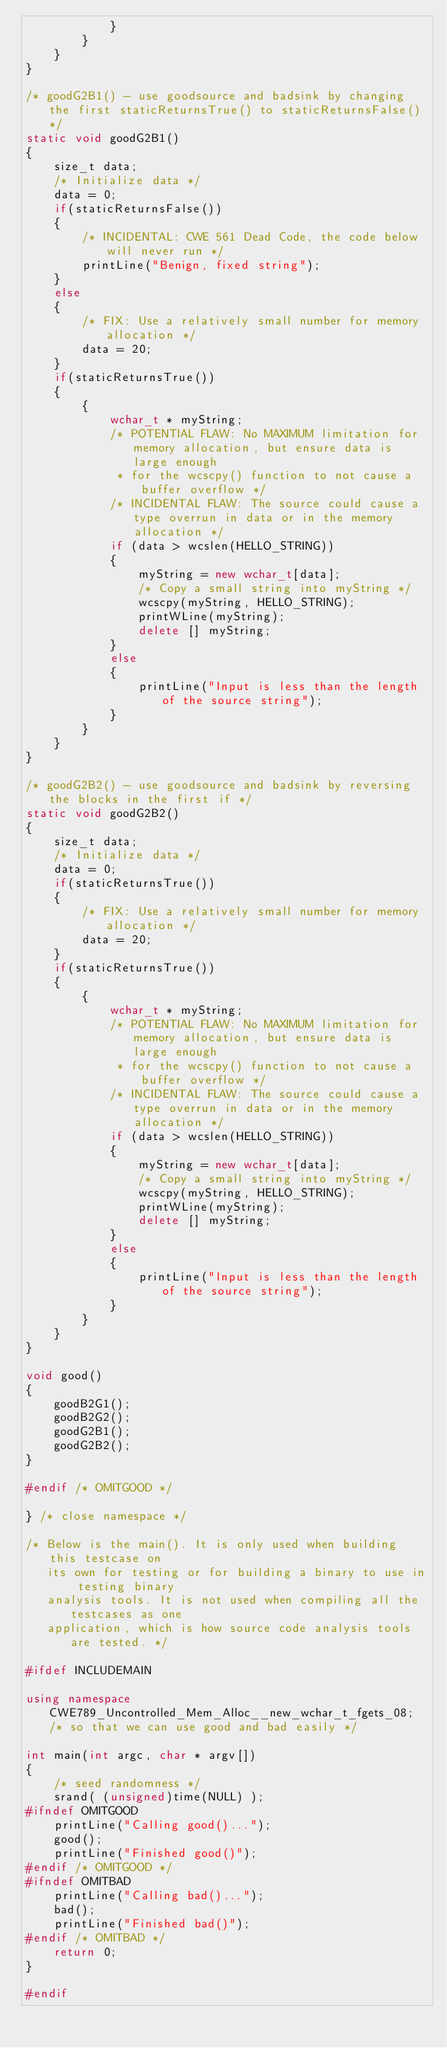<code> <loc_0><loc_0><loc_500><loc_500><_C++_>            }
        }
    }
}

/* goodG2B1() - use goodsource and badsink by changing the first staticReturnsTrue() to staticReturnsFalse() */
static void goodG2B1()
{
    size_t data;
    /* Initialize data */
    data = 0;
    if(staticReturnsFalse())
    {
        /* INCIDENTAL: CWE 561 Dead Code, the code below will never run */
        printLine("Benign, fixed string");
    }
    else
    {
        /* FIX: Use a relatively small number for memory allocation */
        data = 20;
    }
    if(staticReturnsTrue())
    {
        {
            wchar_t * myString;
            /* POTENTIAL FLAW: No MAXIMUM limitation for memory allocation, but ensure data is large enough
             * for the wcscpy() function to not cause a buffer overflow */
            /* INCIDENTAL FLAW: The source could cause a type overrun in data or in the memory allocation */
            if (data > wcslen(HELLO_STRING))
            {
                myString = new wchar_t[data];
                /* Copy a small string into myString */
                wcscpy(myString, HELLO_STRING);
                printWLine(myString);
                delete [] myString;
            }
            else
            {
                printLine("Input is less than the length of the source string");
            }
        }
    }
}

/* goodG2B2() - use goodsource and badsink by reversing the blocks in the first if */
static void goodG2B2()
{
    size_t data;
    /* Initialize data */
    data = 0;
    if(staticReturnsTrue())
    {
        /* FIX: Use a relatively small number for memory allocation */
        data = 20;
    }
    if(staticReturnsTrue())
    {
        {
            wchar_t * myString;
            /* POTENTIAL FLAW: No MAXIMUM limitation for memory allocation, but ensure data is large enough
             * for the wcscpy() function to not cause a buffer overflow */
            /* INCIDENTAL FLAW: The source could cause a type overrun in data or in the memory allocation */
            if (data > wcslen(HELLO_STRING))
            {
                myString = new wchar_t[data];
                /* Copy a small string into myString */
                wcscpy(myString, HELLO_STRING);
                printWLine(myString);
                delete [] myString;
            }
            else
            {
                printLine("Input is less than the length of the source string");
            }
        }
    }
}

void good()
{
    goodB2G1();
    goodB2G2();
    goodG2B1();
    goodG2B2();
}

#endif /* OMITGOOD */

} /* close namespace */

/* Below is the main(). It is only used when building this testcase on
   its own for testing or for building a binary to use in testing binary
   analysis tools. It is not used when compiling all the testcases as one
   application, which is how source code analysis tools are tested. */

#ifdef INCLUDEMAIN

using namespace CWE789_Uncontrolled_Mem_Alloc__new_wchar_t_fgets_08; /* so that we can use good and bad easily */

int main(int argc, char * argv[])
{
    /* seed randomness */
    srand( (unsigned)time(NULL) );
#ifndef OMITGOOD
    printLine("Calling good()...");
    good();
    printLine("Finished good()");
#endif /* OMITGOOD */
#ifndef OMITBAD
    printLine("Calling bad()...");
    bad();
    printLine("Finished bad()");
#endif /* OMITBAD */
    return 0;
}

#endif
</code> 